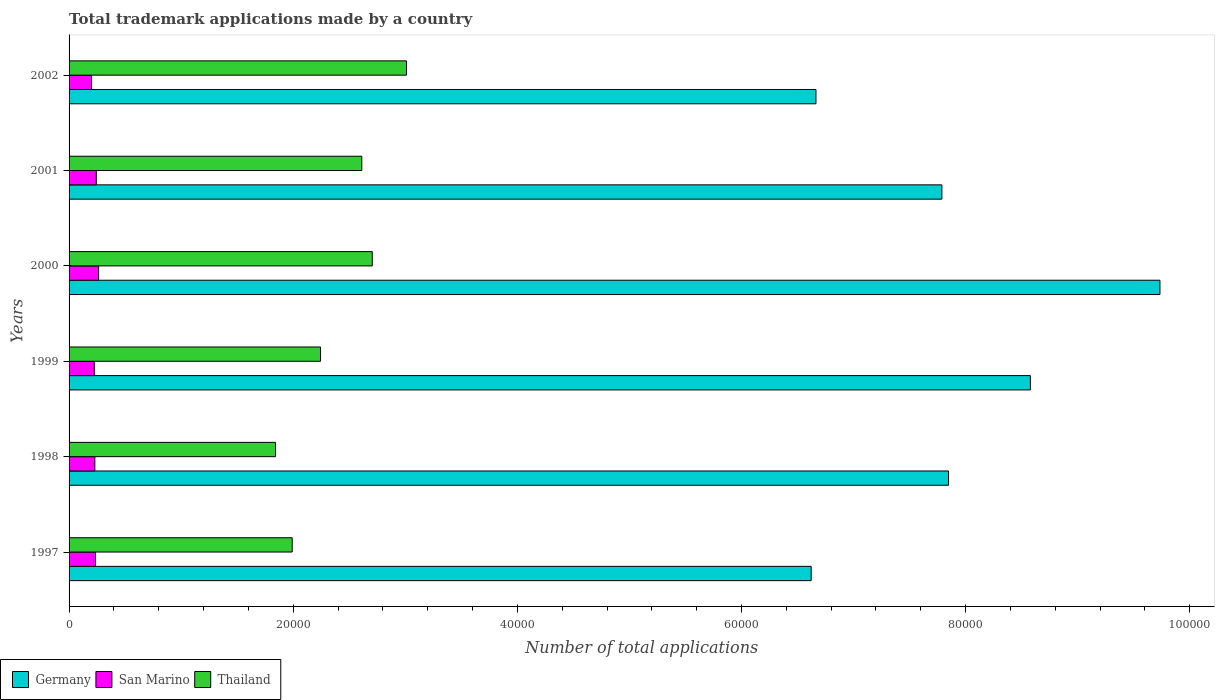What is the label of the 6th group of bars from the top?
Offer a very short reply. 1997. In how many cases, is the number of bars for a given year not equal to the number of legend labels?
Your answer should be compact. 0. What is the number of applications made by in Germany in 2001?
Make the answer very short. 7.79e+04. Across all years, what is the maximum number of applications made by in San Marino?
Your answer should be very brief. 2636. Across all years, what is the minimum number of applications made by in Thailand?
Offer a very short reply. 1.84e+04. In which year was the number of applications made by in Thailand maximum?
Offer a terse response. 2002. In which year was the number of applications made by in Germany minimum?
Your response must be concise. 1997. What is the total number of applications made by in Thailand in the graph?
Your response must be concise. 1.44e+05. What is the difference between the number of applications made by in Thailand in 1999 and that in 2000?
Provide a short and direct response. -4616. What is the difference between the number of applications made by in Thailand in 1998 and the number of applications made by in San Marino in 1999?
Provide a short and direct response. 1.62e+04. What is the average number of applications made by in Germany per year?
Provide a short and direct response. 7.87e+04. In the year 2000, what is the difference between the number of applications made by in Thailand and number of applications made by in Germany?
Provide a succinct answer. -7.03e+04. In how many years, is the number of applications made by in San Marino greater than 16000 ?
Your response must be concise. 0. What is the ratio of the number of applications made by in San Marino in 1997 to that in 2002?
Your answer should be very brief. 1.17. What is the difference between the highest and the second highest number of applications made by in San Marino?
Your answer should be very brief. 207. What is the difference between the highest and the lowest number of applications made by in San Marino?
Give a very brief answer. 634. What does the 3rd bar from the top in 1999 represents?
Your response must be concise. Germany. What does the 1st bar from the bottom in 1997 represents?
Give a very brief answer. Germany. Is it the case that in every year, the sum of the number of applications made by in Germany and number of applications made by in Thailand is greater than the number of applications made by in San Marino?
Your answer should be compact. Yes. How many bars are there?
Offer a terse response. 18. Does the graph contain any zero values?
Provide a short and direct response. No. Where does the legend appear in the graph?
Your answer should be very brief. Bottom left. How are the legend labels stacked?
Make the answer very short. Horizontal. What is the title of the graph?
Your response must be concise. Total trademark applications made by a country. Does "Isle of Man" appear as one of the legend labels in the graph?
Your response must be concise. No. What is the label or title of the X-axis?
Make the answer very short. Number of total applications. What is the label or title of the Y-axis?
Your answer should be very brief. Years. What is the Number of total applications in Germany in 1997?
Give a very brief answer. 6.62e+04. What is the Number of total applications of San Marino in 1997?
Offer a terse response. 2352. What is the Number of total applications in Thailand in 1997?
Provide a succinct answer. 1.99e+04. What is the Number of total applications of Germany in 1998?
Your answer should be compact. 7.85e+04. What is the Number of total applications of San Marino in 1998?
Offer a very short reply. 2299. What is the Number of total applications of Thailand in 1998?
Ensure brevity in your answer.  1.84e+04. What is the Number of total applications of Germany in 1999?
Provide a succinct answer. 8.58e+04. What is the Number of total applications of San Marino in 1999?
Your response must be concise. 2249. What is the Number of total applications in Thailand in 1999?
Offer a terse response. 2.24e+04. What is the Number of total applications in Germany in 2000?
Your response must be concise. 9.73e+04. What is the Number of total applications in San Marino in 2000?
Your answer should be very brief. 2636. What is the Number of total applications in Thailand in 2000?
Provide a short and direct response. 2.71e+04. What is the Number of total applications of Germany in 2001?
Offer a terse response. 7.79e+04. What is the Number of total applications in San Marino in 2001?
Keep it short and to the point. 2429. What is the Number of total applications in Thailand in 2001?
Ensure brevity in your answer.  2.61e+04. What is the Number of total applications in Germany in 2002?
Ensure brevity in your answer.  6.66e+04. What is the Number of total applications of San Marino in 2002?
Offer a very short reply. 2002. What is the Number of total applications of Thailand in 2002?
Give a very brief answer. 3.01e+04. Across all years, what is the maximum Number of total applications in Germany?
Your answer should be very brief. 9.73e+04. Across all years, what is the maximum Number of total applications of San Marino?
Your answer should be very brief. 2636. Across all years, what is the maximum Number of total applications in Thailand?
Make the answer very short. 3.01e+04. Across all years, what is the minimum Number of total applications in Germany?
Offer a terse response. 6.62e+04. Across all years, what is the minimum Number of total applications of San Marino?
Give a very brief answer. 2002. Across all years, what is the minimum Number of total applications in Thailand?
Your response must be concise. 1.84e+04. What is the total Number of total applications of Germany in the graph?
Your answer should be very brief. 4.72e+05. What is the total Number of total applications in San Marino in the graph?
Your answer should be very brief. 1.40e+04. What is the total Number of total applications in Thailand in the graph?
Provide a short and direct response. 1.44e+05. What is the difference between the Number of total applications in Germany in 1997 and that in 1998?
Your response must be concise. -1.23e+04. What is the difference between the Number of total applications of Thailand in 1997 and that in 1998?
Your answer should be compact. 1490. What is the difference between the Number of total applications in Germany in 1997 and that in 1999?
Make the answer very short. -1.96e+04. What is the difference between the Number of total applications in San Marino in 1997 and that in 1999?
Your response must be concise. 103. What is the difference between the Number of total applications in Thailand in 1997 and that in 1999?
Ensure brevity in your answer.  -2530. What is the difference between the Number of total applications of Germany in 1997 and that in 2000?
Offer a very short reply. -3.11e+04. What is the difference between the Number of total applications of San Marino in 1997 and that in 2000?
Keep it short and to the point. -284. What is the difference between the Number of total applications of Thailand in 1997 and that in 2000?
Give a very brief answer. -7146. What is the difference between the Number of total applications of Germany in 1997 and that in 2001?
Give a very brief answer. -1.17e+04. What is the difference between the Number of total applications of San Marino in 1997 and that in 2001?
Your response must be concise. -77. What is the difference between the Number of total applications of Thailand in 1997 and that in 2001?
Your response must be concise. -6210. What is the difference between the Number of total applications of Germany in 1997 and that in 2002?
Provide a succinct answer. -428. What is the difference between the Number of total applications of San Marino in 1997 and that in 2002?
Provide a succinct answer. 350. What is the difference between the Number of total applications in Thailand in 1997 and that in 2002?
Your response must be concise. -1.02e+04. What is the difference between the Number of total applications of Germany in 1998 and that in 1999?
Give a very brief answer. -7305. What is the difference between the Number of total applications of Thailand in 1998 and that in 1999?
Keep it short and to the point. -4020. What is the difference between the Number of total applications of Germany in 1998 and that in 2000?
Provide a short and direct response. -1.89e+04. What is the difference between the Number of total applications in San Marino in 1998 and that in 2000?
Your answer should be compact. -337. What is the difference between the Number of total applications of Thailand in 1998 and that in 2000?
Provide a short and direct response. -8636. What is the difference between the Number of total applications of Germany in 1998 and that in 2001?
Your answer should be very brief. 592. What is the difference between the Number of total applications in San Marino in 1998 and that in 2001?
Ensure brevity in your answer.  -130. What is the difference between the Number of total applications of Thailand in 1998 and that in 2001?
Offer a very short reply. -7700. What is the difference between the Number of total applications of Germany in 1998 and that in 2002?
Provide a succinct answer. 1.18e+04. What is the difference between the Number of total applications of San Marino in 1998 and that in 2002?
Offer a very short reply. 297. What is the difference between the Number of total applications of Thailand in 1998 and that in 2002?
Give a very brief answer. -1.17e+04. What is the difference between the Number of total applications of Germany in 1999 and that in 2000?
Offer a terse response. -1.16e+04. What is the difference between the Number of total applications of San Marino in 1999 and that in 2000?
Offer a terse response. -387. What is the difference between the Number of total applications of Thailand in 1999 and that in 2000?
Offer a terse response. -4616. What is the difference between the Number of total applications in Germany in 1999 and that in 2001?
Give a very brief answer. 7897. What is the difference between the Number of total applications in San Marino in 1999 and that in 2001?
Offer a very short reply. -180. What is the difference between the Number of total applications of Thailand in 1999 and that in 2001?
Ensure brevity in your answer.  -3680. What is the difference between the Number of total applications in Germany in 1999 and that in 2002?
Make the answer very short. 1.91e+04. What is the difference between the Number of total applications in San Marino in 1999 and that in 2002?
Offer a very short reply. 247. What is the difference between the Number of total applications of Thailand in 1999 and that in 2002?
Your response must be concise. -7670. What is the difference between the Number of total applications in Germany in 2000 and that in 2001?
Offer a very short reply. 1.95e+04. What is the difference between the Number of total applications of San Marino in 2000 and that in 2001?
Keep it short and to the point. 207. What is the difference between the Number of total applications of Thailand in 2000 and that in 2001?
Provide a short and direct response. 936. What is the difference between the Number of total applications in Germany in 2000 and that in 2002?
Ensure brevity in your answer.  3.07e+04. What is the difference between the Number of total applications of San Marino in 2000 and that in 2002?
Your response must be concise. 634. What is the difference between the Number of total applications of Thailand in 2000 and that in 2002?
Your response must be concise. -3054. What is the difference between the Number of total applications of Germany in 2001 and that in 2002?
Provide a succinct answer. 1.12e+04. What is the difference between the Number of total applications of San Marino in 2001 and that in 2002?
Your answer should be very brief. 427. What is the difference between the Number of total applications in Thailand in 2001 and that in 2002?
Keep it short and to the point. -3990. What is the difference between the Number of total applications in Germany in 1997 and the Number of total applications in San Marino in 1998?
Keep it short and to the point. 6.39e+04. What is the difference between the Number of total applications of Germany in 1997 and the Number of total applications of Thailand in 1998?
Ensure brevity in your answer.  4.78e+04. What is the difference between the Number of total applications in San Marino in 1997 and the Number of total applications in Thailand in 1998?
Your response must be concise. -1.61e+04. What is the difference between the Number of total applications in Germany in 1997 and the Number of total applications in San Marino in 1999?
Provide a succinct answer. 6.40e+04. What is the difference between the Number of total applications in Germany in 1997 and the Number of total applications in Thailand in 1999?
Keep it short and to the point. 4.38e+04. What is the difference between the Number of total applications in San Marino in 1997 and the Number of total applications in Thailand in 1999?
Your answer should be very brief. -2.01e+04. What is the difference between the Number of total applications of Germany in 1997 and the Number of total applications of San Marino in 2000?
Give a very brief answer. 6.36e+04. What is the difference between the Number of total applications in Germany in 1997 and the Number of total applications in Thailand in 2000?
Offer a very short reply. 3.92e+04. What is the difference between the Number of total applications of San Marino in 1997 and the Number of total applications of Thailand in 2000?
Offer a very short reply. -2.47e+04. What is the difference between the Number of total applications in Germany in 1997 and the Number of total applications in San Marino in 2001?
Keep it short and to the point. 6.38e+04. What is the difference between the Number of total applications in Germany in 1997 and the Number of total applications in Thailand in 2001?
Offer a terse response. 4.01e+04. What is the difference between the Number of total applications in San Marino in 1997 and the Number of total applications in Thailand in 2001?
Make the answer very short. -2.38e+04. What is the difference between the Number of total applications of Germany in 1997 and the Number of total applications of San Marino in 2002?
Make the answer very short. 6.42e+04. What is the difference between the Number of total applications in Germany in 1997 and the Number of total applications in Thailand in 2002?
Make the answer very short. 3.61e+04. What is the difference between the Number of total applications of San Marino in 1997 and the Number of total applications of Thailand in 2002?
Provide a short and direct response. -2.78e+04. What is the difference between the Number of total applications in Germany in 1998 and the Number of total applications in San Marino in 1999?
Provide a succinct answer. 7.62e+04. What is the difference between the Number of total applications in Germany in 1998 and the Number of total applications in Thailand in 1999?
Make the answer very short. 5.60e+04. What is the difference between the Number of total applications in San Marino in 1998 and the Number of total applications in Thailand in 1999?
Give a very brief answer. -2.01e+04. What is the difference between the Number of total applications of Germany in 1998 and the Number of total applications of San Marino in 2000?
Keep it short and to the point. 7.58e+04. What is the difference between the Number of total applications of Germany in 1998 and the Number of total applications of Thailand in 2000?
Your response must be concise. 5.14e+04. What is the difference between the Number of total applications in San Marino in 1998 and the Number of total applications in Thailand in 2000?
Offer a terse response. -2.48e+04. What is the difference between the Number of total applications of Germany in 1998 and the Number of total applications of San Marino in 2001?
Your response must be concise. 7.60e+04. What is the difference between the Number of total applications of Germany in 1998 and the Number of total applications of Thailand in 2001?
Offer a very short reply. 5.24e+04. What is the difference between the Number of total applications of San Marino in 1998 and the Number of total applications of Thailand in 2001?
Your response must be concise. -2.38e+04. What is the difference between the Number of total applications of Germany in 1998 and the Number of total applications of San Marino in 2002?
Provide a succinct answer. 7.65e+04. What is the difference between the Number of total applications in Germany in 1998 and the Number of total applications in Thailand in 2002?
Offer a terse response. 4.84e+04. What is the difference between the Number of total applications of San Marino in 1998 and the Number of total applications of Thailand in 2002?
Provide a short and direct response. -2.78e+04. What is the difference between the Number of total applications in Germany in 1999 and the Number of total applications in San Marino in 2000?
Provide a succinct answer. 8.31e+04. What is the difference between the Number of total applications in Germany in 1999 and the Number of total applications in Thailand in 2000?
Offer a terse response. 5.87e+04. What is the difference between the Number of total applications in San Marino in 1999 and the Number of total applications in Thailand in 2000?
Provide a short and direct response. -2.48e+04. What is the difference between the Number of total applications of Germany in 1999 and the Number of total applications of San Marino in 2001?
Your answer should be compact. 8.33e+04. What is the difference between the Number of total applications of Germany in 1999 and the Number of total applications of Thailand in 2001?
Provide a succinct answer. 5.97e+04. What is the difference between the Number of total applications of San Marino in 1999 and the Number of total applications of Thailand in 2001?
Provide a short and direct response. -2.39e+04. What is the difference between the Number of total applications of Germany in 1999 and the Number of total applications of San Marino in 2002?
Your answer should be compact. 8.38e+04. What is the difference between the Number of total applications of Germany in 1999 and the Number of total applications of Thailand in 2002?
Make the answer very short. 5.57e+04. What is the difference between the Number of total applications in San Marino in 1999 and the Number of total applications in Thailand in 2002?
Give a very brief answer. -2.79e+04. What is the difference between the Number of total applications of Germany in 2000 and the Number of total applications of San Marino in 2001?
Provide a succinct answer. 9.49e+04. What is the difference between the Number of total applications of Germany in 2000 and the Number of total applications of Thailand in 2001?
Your answer should be compact. 7.12e+04. What is the difference between the Number of total applications of San Marino in 2000 and the Number of total applications of Thailand in 2001?
Your answer should be very brief. -2.35e+04. What is the difference between the Number of total applications in Germany in 2000 and the Number of total applications in San Marino in 2002?
Provide a succinct answer. 9.53e+04. What is the difference between the Number of total applications of Germany in 2000 and the Number of total applications of Thailand in 2002?
Your response must be concise. 6.72e+04. What is the difference between the Number of total applications of San Marino in 2000 and the Number of total applications of Thailand in 2002?
Provide a short and direct response. -2.75e+04. What is the difference between the Number of total applications in Germany in 2001 and the Number of total applications in San Marino in 2002?
Provide a short and direct response. 7.59e+04. What is the difference between the Number of total applications in Germany in 2001 and the Number of total applications in Thailand in 2002?
Keep it short and to the point. 4.78e+04. What is the difference between the Number of total applications of San Marino in 2001 and the Number of total applications of Thailand in 2002?
Your response must be concise. -2.77e+04. What is the average Number of total applications of Germany per year?
Offer a very short reply. 7.87e+04. What is the average Number of total applications in San Marino per year?
Give a very brief answer. 2327.83. What is the average Number of total applications of Thailand per year?
Offer a terse response. 2.40e+04. In the year 1997, what is the difference between the Number of total applications of Germany and Number of total applications of San Marino?
Your answer should be very brief. 6.39e+04. In the year 1997, what is the difference between the Number of total applications in Germany and Number of total applications in Thailand?
Give a very brief answer. 4.63e+04. In the year 1997, what is the difference between the Number of total applications in San Marino and Number of total applications in Thailand?
Ensure brevity in your answer.  -1.76e+04. In the year 1998, what is the difference between the Number of total applications of Germany and Number of total applications of San Marino?
Make the answer very short. 7.62e+04. In the year 1998, what is the difference between the Number of total applications in Germany and Number of total applications in Thailand?
Ensure brevity in your answer.  6.01e+04. In the year 1998, what is the difference between the Number of total applications in San Marino and Number of total applications in Thailand?
Provide a short and direct response. -1.61e+04. In the year 1999, what is the difference between the Number of total applications in Germany and Number of total applications in San Marino?
Make the answer very short. 8.35e+04. In the year 1999, what is the difference between the Number of total applications of Germany and Number of total applications of Thailand?
Give a very brief answer. 6.33e+04. In the year 1999, what is the difference between the Number of total applications in San Marino and Number of total applications in Thailand?
Offer a terse response. -2.02e+04. In the year 2000, what is the difference between the Number of total applications in Germany and Number of total applications in San Marino?
Provide a succinct answer. 9.47e+04. In the year 2000, what is the difference between the Number of total applications in Germany and Number of total applications in Thailand?
Ensure brevity in your answer.  7.03e+04. In the year 2000, what is the difference between the Number of total applications in San Marino and Number of total applications in Thailand?
Provide a succinct answer. -2.44e+04. In the year 2001, what is the difference between the Number of total applications of Germany and Number of total applications of San Marino?
Keep it short and to the point. 7.55e+04. In the year 2001, what is the difference between the Number of total applications of Germany and Number of total applications of Thailand?
Give a very brief answer. 5.18e+04. In the year 2001, what is the difference between the Number of total applications of San Marino and Number of total applications of Thailand?
Your answer should be very brief. -2.37e+04. In the year 2002, what is the difference between the Number of total applications in Germany and Number of total applications in San Marino?
Make the answer very short. 6.46e+04. In the year 2002, what is the difference between the Number of total applications in Germany and Number of total applications in Thailand?
Your answer should be compact. 3.65e+04. In the year 2002, what is the difference between the Number of total applications of San Marino and Number of total applications of Thailand?
Your answer should be very brief. -2.81e+04. What is the ratio of the Number of total applications in Germany in 1997 to that in 1998?
Make the answer very short. 0.84. What is the ratio of the Number of total applications in San Marino in 1997 to that in 1998?
Your answer should be very brief. 1.02. What is the ratio of the Number of total applications of Thailand in 1997 to that in 1998?
Make the answer very short. 1.08. What is the ratio of the Number of total applications of Germany in 1997 to that in 1999?
Your answer should be very brief. 0.77. What is the ratio of the Number of total applications of San Marino in 1997 to that in 1999?
Provide a short and direct response. 1.05. What is the ratio of the Number of total applications of Thailand in 1997 to that in 1999?
Your answer should be very brief. 0.89. What is the ratio of the Number of total applications of Germany in 1997 to that in 2000?
Offer a very short reply. 0.68. What is the ratio of the Number of total applications in San Marino in 1997 to that in 2000?
Ensure brevity in your answer.  0.89. What is the ratio of the Number of total applications in Thailand in 1997 to that in 2000?
Keep it short and to the point. 0.74. What is the ratio of the Number of total applications in Germany in 1997 to that in 2001?
Provide a short and direct response. 0.85. What is the ratio of the Number of total applications of San Marino in 1997 to that in 2001?
Provide a succinct answer. 0.97. What is the ratio of the Number of total applications in Thailand in 1997 to that in 2001?
Your response must be concise. 0.76. What is the ratio of the Number of total applications of Germany in 1997 to that in 2002?
Keep it short and to the point. 0.99. What is the ratio of the Number of total applications of San Marino in 1997 to that in 2002?
Keep it short and to the point. 1.17. What is the ratio of the Number of total applications of Thailand in 1997 to that in 2002?
Offer a terse response. 0.66. What is the ratio of the Number of total applications of Germany in 1998 to that in 1999?
Give a very brief answer. 0.91. What is the ratio of the Number of total applications in San Marino in 1998 to that in 1999?
Make the answer very short. 1.02. What is the ratio of the Number of total applications in Thailand in 1998 to that in 1999?
Give a very brief answer. 0.82. What is the ratio of the Number of total applications in Germany in 1998 to that in 2000?
Provide a short and direct response. 0.81. What is the ratio of the Number of total applications in San Marino in 1998 to that in 2000?
Your answer should be very brief. 0.87. What is the ratio of the Number of total applications of Thailand in 1998 to that in 2000?
Give a very brief answer. 0.68. What is the ratio of the Number of total applications in Germany in 1998 to that in 2001?
Your answer should be very brief. 1.01. What is the ratio of the Number of total applications in San Marino in 1998 to that in 2001?
Your answer should be compact. 0.95. What is the ratio of the Number of total applications in Thailand in 1998 to that in 2001?
Offer a terse response. 0.71. What is the ratio of the Number of total applications in Germany in 1998 to that in 2002?
Make the answer very short. 1.18. What is the ratio of the Number of total applications in San Marino in 1998 to that in 2002?
Make the answer very short. 1.15. What is the ratio of the Number of total applications in Thailand in 1998 to that in 2002?
Your response must be concise. 0.61. What is the ratio of the Number of total applications of Germany in 1999 to that in 2000?
Ensure brevity in your answer.  0.88. What is the ratio of the Number of total applications of San Marino in 1999 to that in 2000?
Ensure brevity in your answer.  0.85. What is the ratio of the Number of total applications of Thailand in 1999 to that in 2000?
Ensure brevity in your answer.  0.83. What is the ratio of the Number of total applications in Germany in 1999 to that in 2001?
Keep it short and to the point. 1.1. What is the ratio of the Number of total applications in San Marino in 1999 to that in 2001?
Your answer should be very brief. 0.93. What is the ratio of the Number of total applications of Thailand in 1999 to that in 2001?
Ensure brevity in your answer.  0.86. What is the ratio of the Number of total applications in Germany in 1999 to that in 2002?
Offer a terse response. 1.29. What is the ratio of the Number of total applications in San Marino in 1999 to that in 2002?
Your answer should be very brief. 1.12. What is the ratio of the Number of total applications in Thailand in 1999 to that in 2002?
Offer a very short reply. 0.75. What is the ratio of the Number of total applications of Germany in 2000 to that in 2001?
Provide a succinct answer. 1.25. What is the ratio of the Number of total applications of San Marino in 2000 to that in 2001?
Make the answer very short. 1.09. What is the ratio of the Number of total applications in Thailand in 2000 to that in 2001?
Your response must be concise. 1.04. What is the ratio of the Number of total applications in Germany in 2000 to that in 2002?
Keep it short and to the point. 1.46. What is the ratio of the Number of total applications of San Marino in 2000 to that in 2002?
Offer a terse response. 1.32. What is the ratio of the Number of total applications of Thailand in 2000 to that in 2002?
Keep it short and to the point. 0.9. What is the ratio of the Number of total applications of Germany in 2001 to that in 2002?
Give a very brief answer. 1.17. What is the ratio of the Number of total applications in San Marino in 2001 to that in 2002?
Ensure brevity in your answer.  1.21. What is the ratio of the Number of total applications in Thailand in 2001 to that in 2002?
Your answer should be very brief. 0.87. What is the difference between the highest and the second highest Number of total applications in Germany?
Provide a succinct answer. 1.16e+04. What is the difference between the highest and the second highest Number of total applications of San Marino?
Ensure brevity in your answer.  207. What is the difference between the highest and the second highest Number of total applications in Thailand?
Offer a very short reply. 3054. What is the difference between the highest and the lowest Number of total applications in Germany?
Your response must be concise. 3.11e+04. What is the difference between the highest and the lowest Number of total applications in San Marino?
Ensure brevity in your answer.  634. What is the difference between the highest and the lowest Number of total applications in Thailand?
Give a very brief answer. 1.17e+04. 